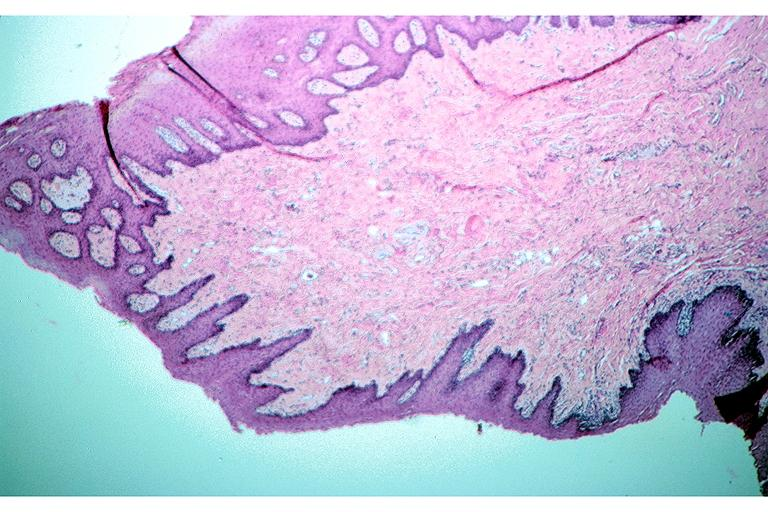s lower chest and abdomen anterior present?
Answer the question using a single word or phrase. No 